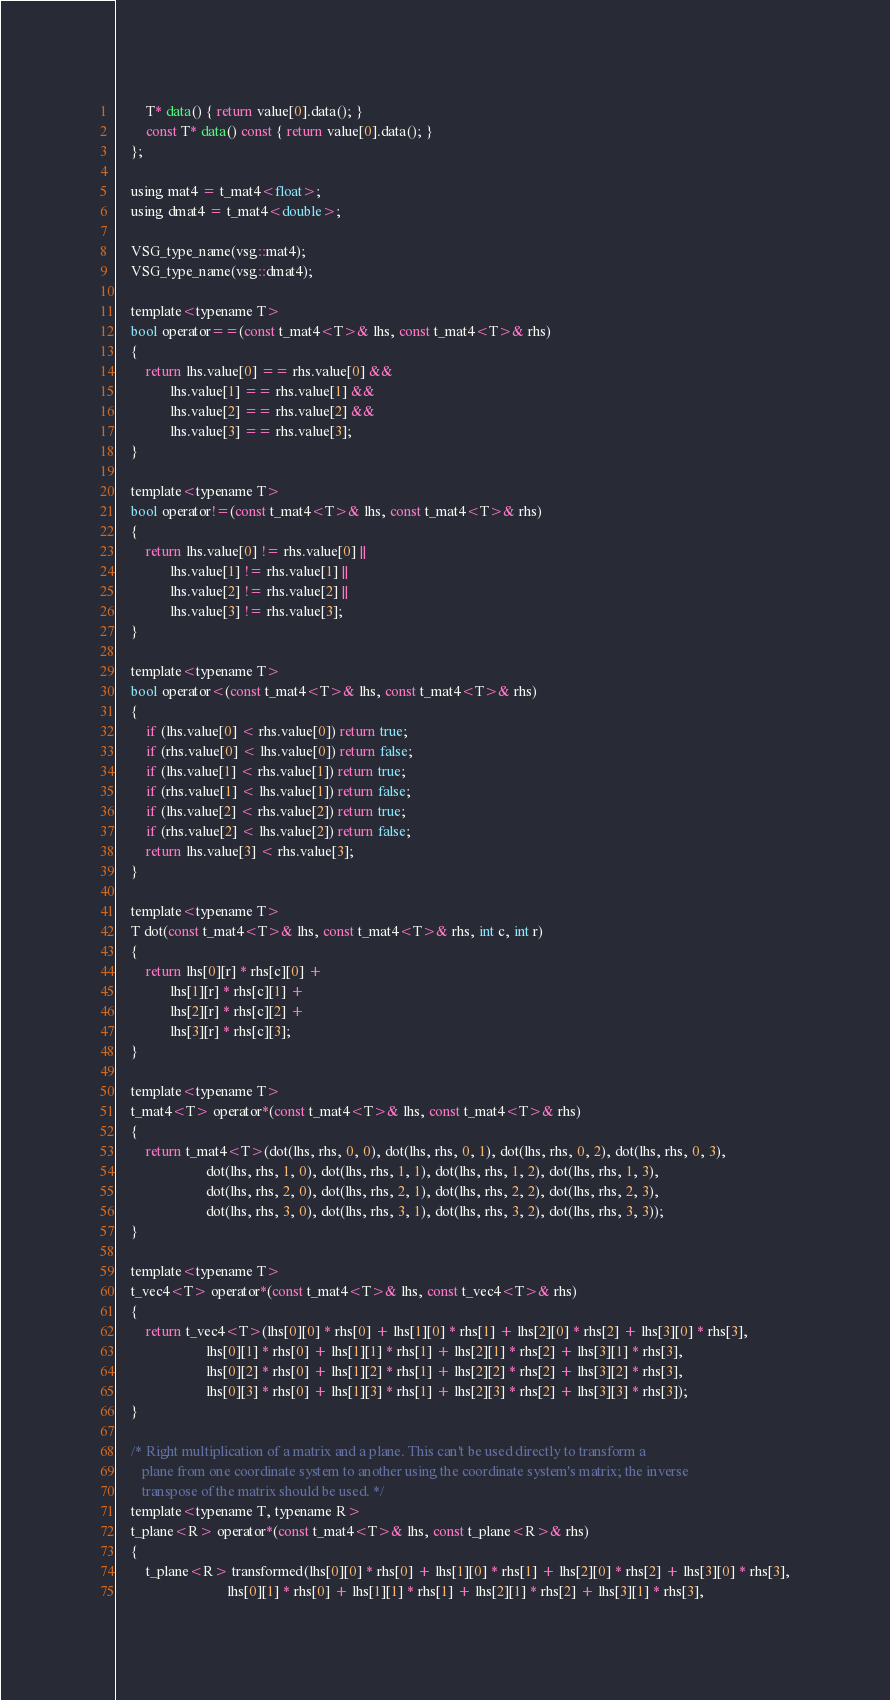Convert code to text. <code><loc_0><loc_0><loc_500><loc_500><_C_>        T* data() { return value[0].data(); }
        const T* data() const { return value[0].data(); }
    };

    using mat4 = t_mat4<float>;
    using dmat4 = t_mat4<double>;

    VSG_type_name(vsg::mat4);
    VSG_type_name(vsg::dmat4);

    template<typename T>
    bool operator==(const t_mat4<T>& lhs, const t_mat4<T>& rhs)
    {
        return lhs.value[0] == rhs.value[0] &&
               lhs.value[1] == rhs.value[1] &&
               lhs.value[2] == rhs.value[2] &&
               lhs.value[3] == rhs.value[3];
    }

    template<typename T>
    bool operator!=(const t_mat4<T>& lhs, const t_mat4<T>& rhs)
    {
        return lhs.value[0] != rhs.value[0] ||
               lhs.value[1] != rhs.value[1] ||
               lhs.value[2] != rhs.value[2] ||
               lhs.value[3] != rhs.value[3];
    }

    template<typename T>
    bool operator<(const t_mat4<T>& lhs, const t_mat4<T>& rhs)
    {
        if (lhs.value[0] < rhs.value[0]) return true;
        if (rhs.value[0] < lhs.value[0]) return false;
        if (lhs.value[1] < rhs.value[1]) return true;
        if (rhs.value[1] < lhs.value[1]) return false;
        if (lhs.value[2] < rhs.value[2]) return true;
        if (rhs.value[2] < lhs.value[2]) return false;
        return lhs.value[3] < rhs.value[3];
    }

    template<typename T>
    T dot(const t_mat4<T>& lhs, const t_mat4<T>& rhs, int c, int r)
    {
        return lhs[0][r] * rhs[c][0] +
               lhs[1][r] * rhs[c][1] +
               lhs[2][r] * rhs[c][2] +
               lhs[3][r] * rhs[c][3];
    }

    template<typename T>
    t_mat4<T> operator*(const t_mat4<T>& lhs, const t_mat4<T>& rhs)
    {
        return t_mat4<T>(dot(lhs, rhs, 0, 0), dot(lhs, rhs, 0, 1), dot(lhs, rhs, 0, 2), dot(lhs, rhs, 0, 3),
                         dot(lhs, rhs, 1, 0), dot(lhs, rhs, 1, 1), dot(lhs, rhs, 1, 2), dot(lhs, rhs, 1, 3),
                         dot(lhs, rhs, 2, 0), dot(lhs, rhs, 2, 1), dot(lhs, rhs, 2, 2), dot(lhs, rhs, 2, 3),
                         dot(lhs, rhs, 3, 0), dot(lhs, rhs, 3, 1), dot(lhs, rhs, 3, 2), dot(lhs, rhs, 3, 3));
    }

    template<typename T>
    t_vec4<T> operator*(const t_mat4<T>& lhs, const t_vec4<T>& rhs)
    {
        return t_vec4<T>(lhs[0][0] * rhs[0] + lhs[1][0] * rhs[1] + lhs[2][0] * rhs[2] + lhs[3][0] * rhs[3],
                         lhs[0][1] * rhs[0] + lhs[1][1] * rhs[1] + lhs[2][1] * rhs[2] + lhs[3][1] * rhs[3],
                         lhs[0][2] * rhs[0] + lhs[1][2] * rhs[1] + lhs[2][2] * rhs[2] + lhs[3][2] * rhs[3],
                         lhs[0][3] * rhs[0] + lhs[1][3] * rhs[1] + lhs[2][3] * rhs[2] + lhs[3][3] * rhs[3]);
    }

    /* Right multiplication of a matrix and a plane. This can't be used directly to transform a
       plane from one coordinate system to another using the coordinate system's matrix; the inverse
       transpose of the matrix should be used. */
    template<typename T, typename R>
    t_plane<R> operator*(const t_mat4<T>& lhs, const t_plane<R>& rhs)
    {
        t_plane<R> transformed(lhs[0][0] * rhs[0] + lhs[1][0] * rhs[1] + lhs[2][0] * rhs[2] + lhs[3][0] * rhs[3],
                               lhs[0][1] * rhs[0] + lhs[1][1] * rhs[1] + lhs[2][1] * rhs[2] + lhs[3][1] * rhs[3],</code> 